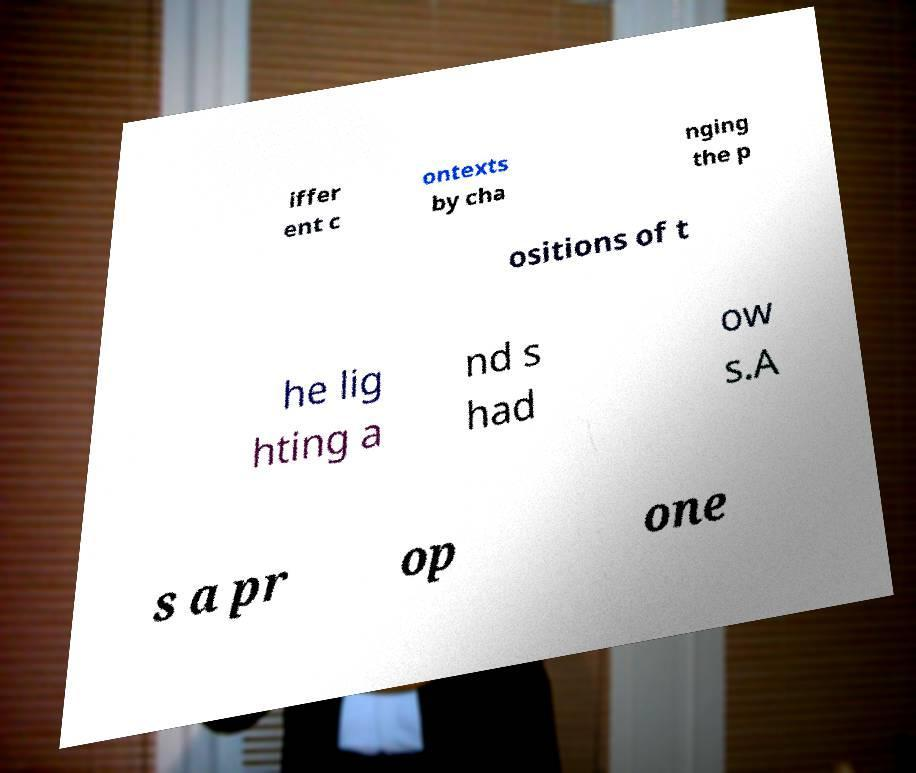Can you accurately transcribe the text from the provided image for me? iffer ent c ontexts by cha nging the p ositions of t he lig hting a nd s had ow s.A s a pr op one 